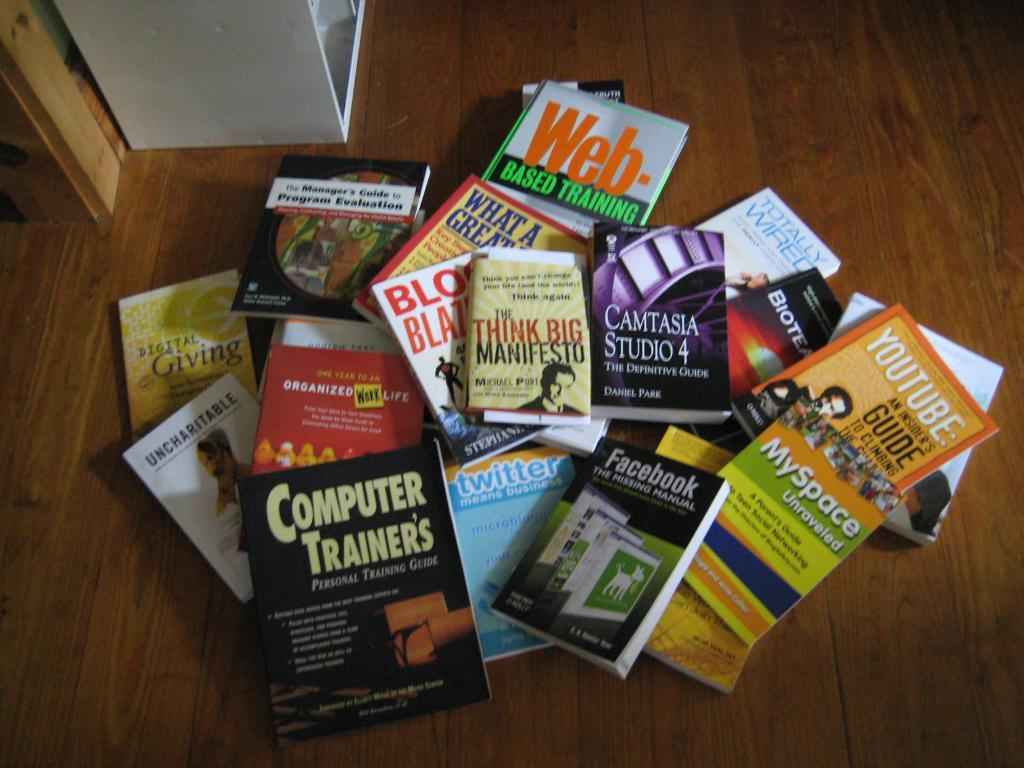<image>
Write a terse but informative summary of the picture. Several different books scattered on a wooden floor about technology. 